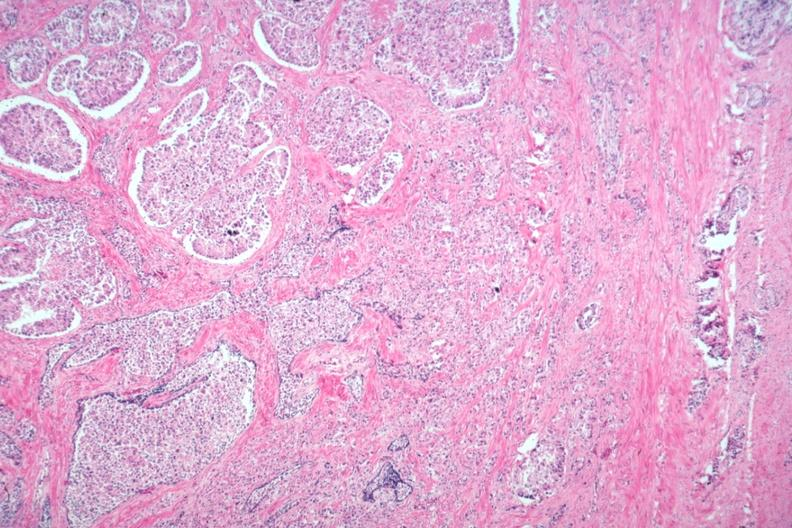what is present?
Answer the question using a single word or phrase. Adenocarcinoma 